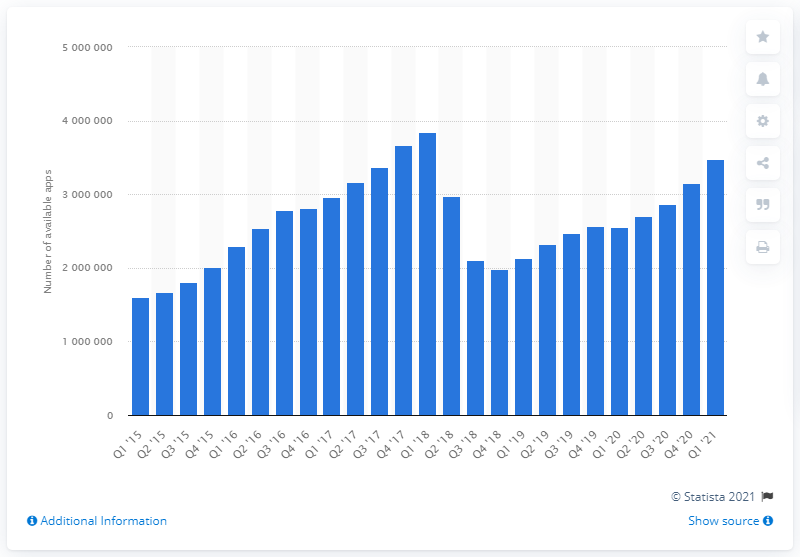Highlight a few significant elements in this photo. As of the first quarter of 2021, there were approximately 348,245,236 mobile apps available for download. 